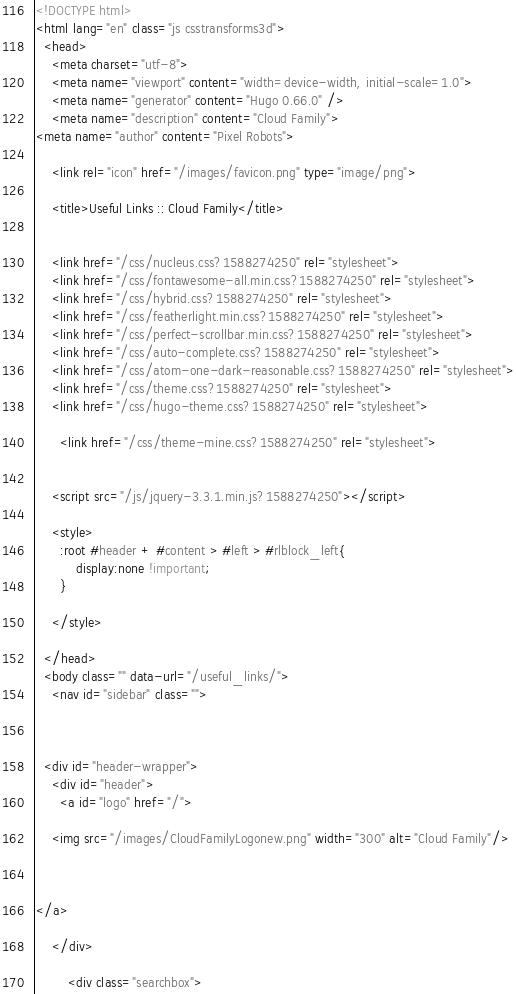<code> <loc_0><loc_0><loc_500><loc_500><_HTML_><!DOCTYPE html>
<html lang="en" class="js csstransforms3d">
  <head>
    <meta charset="utf-8">
    <meta name="viewport" content="width=device-width, initial-scale=1.0">
    <meta name="generator" content="Hugo 0.66.0" />
    <meta name="description" content="Cloud Family">
<meta name="author" content="Pixel Robots">

    <link rel="icon" href="/images/favicon.png" type="image/png">

    <title>Useful Links :: Cloud Family</title>

    
    <link href="/css/nucleus.css?1588274250" rel="stylesheet">
    <link href="/css/fontawesome-all.min.css?1588274250" rel="stylesheet">
    <link href="/css/hybrid.css?1588274250" rel="stylesheet">
    <link href="/css/featherlight.min.css?1588274250" rel="stylesheet">
    <link href="/css/perfect-scrollbar.min.css?1588274250" rel="stylesheet">
    <link href="/css/auto-complete.css?1588274250" rel="stylesheet">
    <link href="/css/atom-one-dark-reasonable.css?1588274250" rel="stylesheet">
    <link href="/css/theme.css?1588274250" rel="stylesheet">
    <link href="/css/hugo-theme.css?1588274250" rel="stylesheet">
    
      <link href="/css/theme-mine.css?1588274250" rel="stylesheet">
    

    <script src="/js/jquery-3.3.1.min.js?1588274250"></script>

    <style>
      :root #header + #content > #left > #rlblock_left{
          display:none !important;
      }
      
    </style>
    
  </head>
  <body class="" data-url="/useful_links/">
    <nav id="sidebar" class="">



  <div id="header-wrapper">
    <div id="header">
      <a id="logo" href="/">

	<img src="/images/CloudFamilyLogonew.png" width="300" alt="Cloud Family"/>

	

</a>

    </div>
    
        <div class="searchbox"></code> 